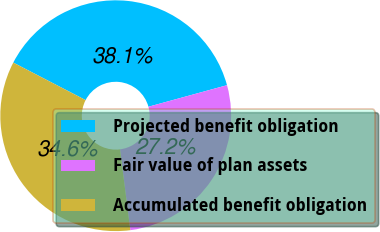<chart> <loc_0><loc_0><loc_500><loc_500><pie_chart><fcel>Projected benefit obligation<fcel>Fair value of plan assets<fcel>Accumulated benefit obligation<nl><fcel>38.13%<fcel>27.24%<fcel>34.63%<nl></chart> 